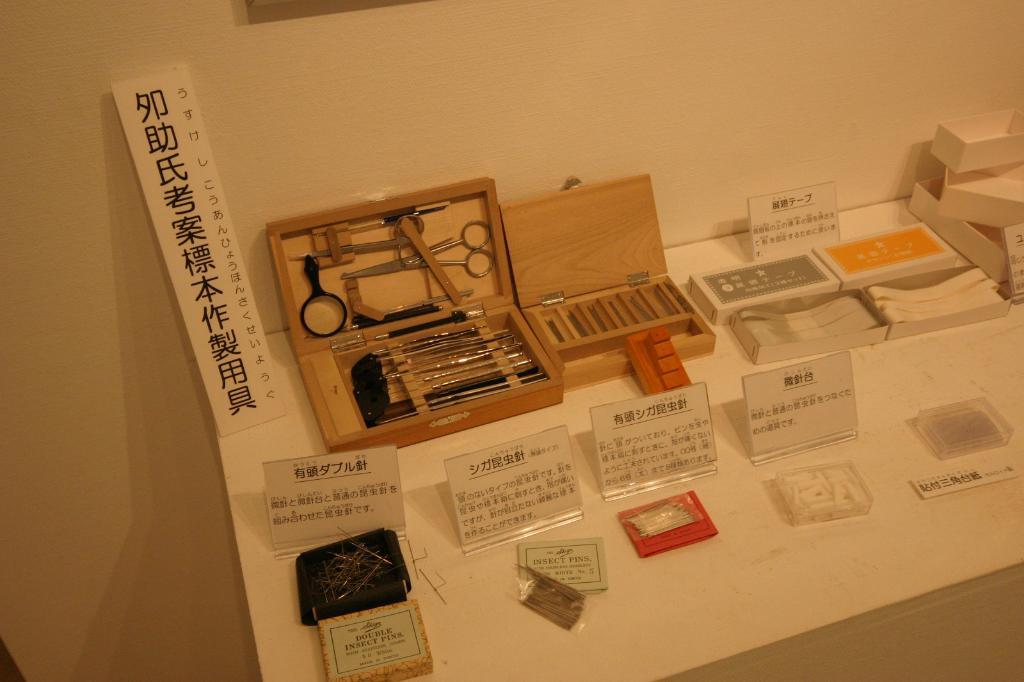<image>
Relay a brief, clear account of the picture shown. many different items that have Japanese writing on them 